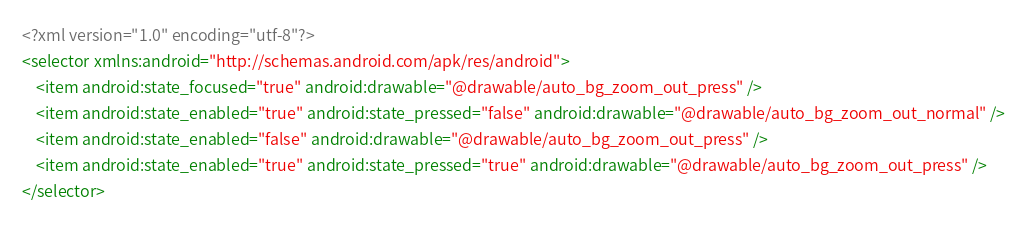Convert code to text. <code><loc_0><loc_0><loc_500><loc_500><_XML_><?xml version="1.0" encoding="utf-8"?>
<selector xmlns:android="http://schemas.android.com/apk/res/android">
    <item android:state_focused="true" android:drawable="@drawable/auto_bg_zoom_out_press" />
    <item android:state_enabled="true" android:state_pressed="false" android:drawable="@drawable/auto_bg_zoom_out_normal" />
    <item android:state_enabled="false" android:drawable="@drawable/auto_bg_zoom_out_press" />
    <item android:state_enabled="true" android:state_pressed="true" android:drawable="@drawable/auto_bg_zoom_out_press" />
</selector></code> 